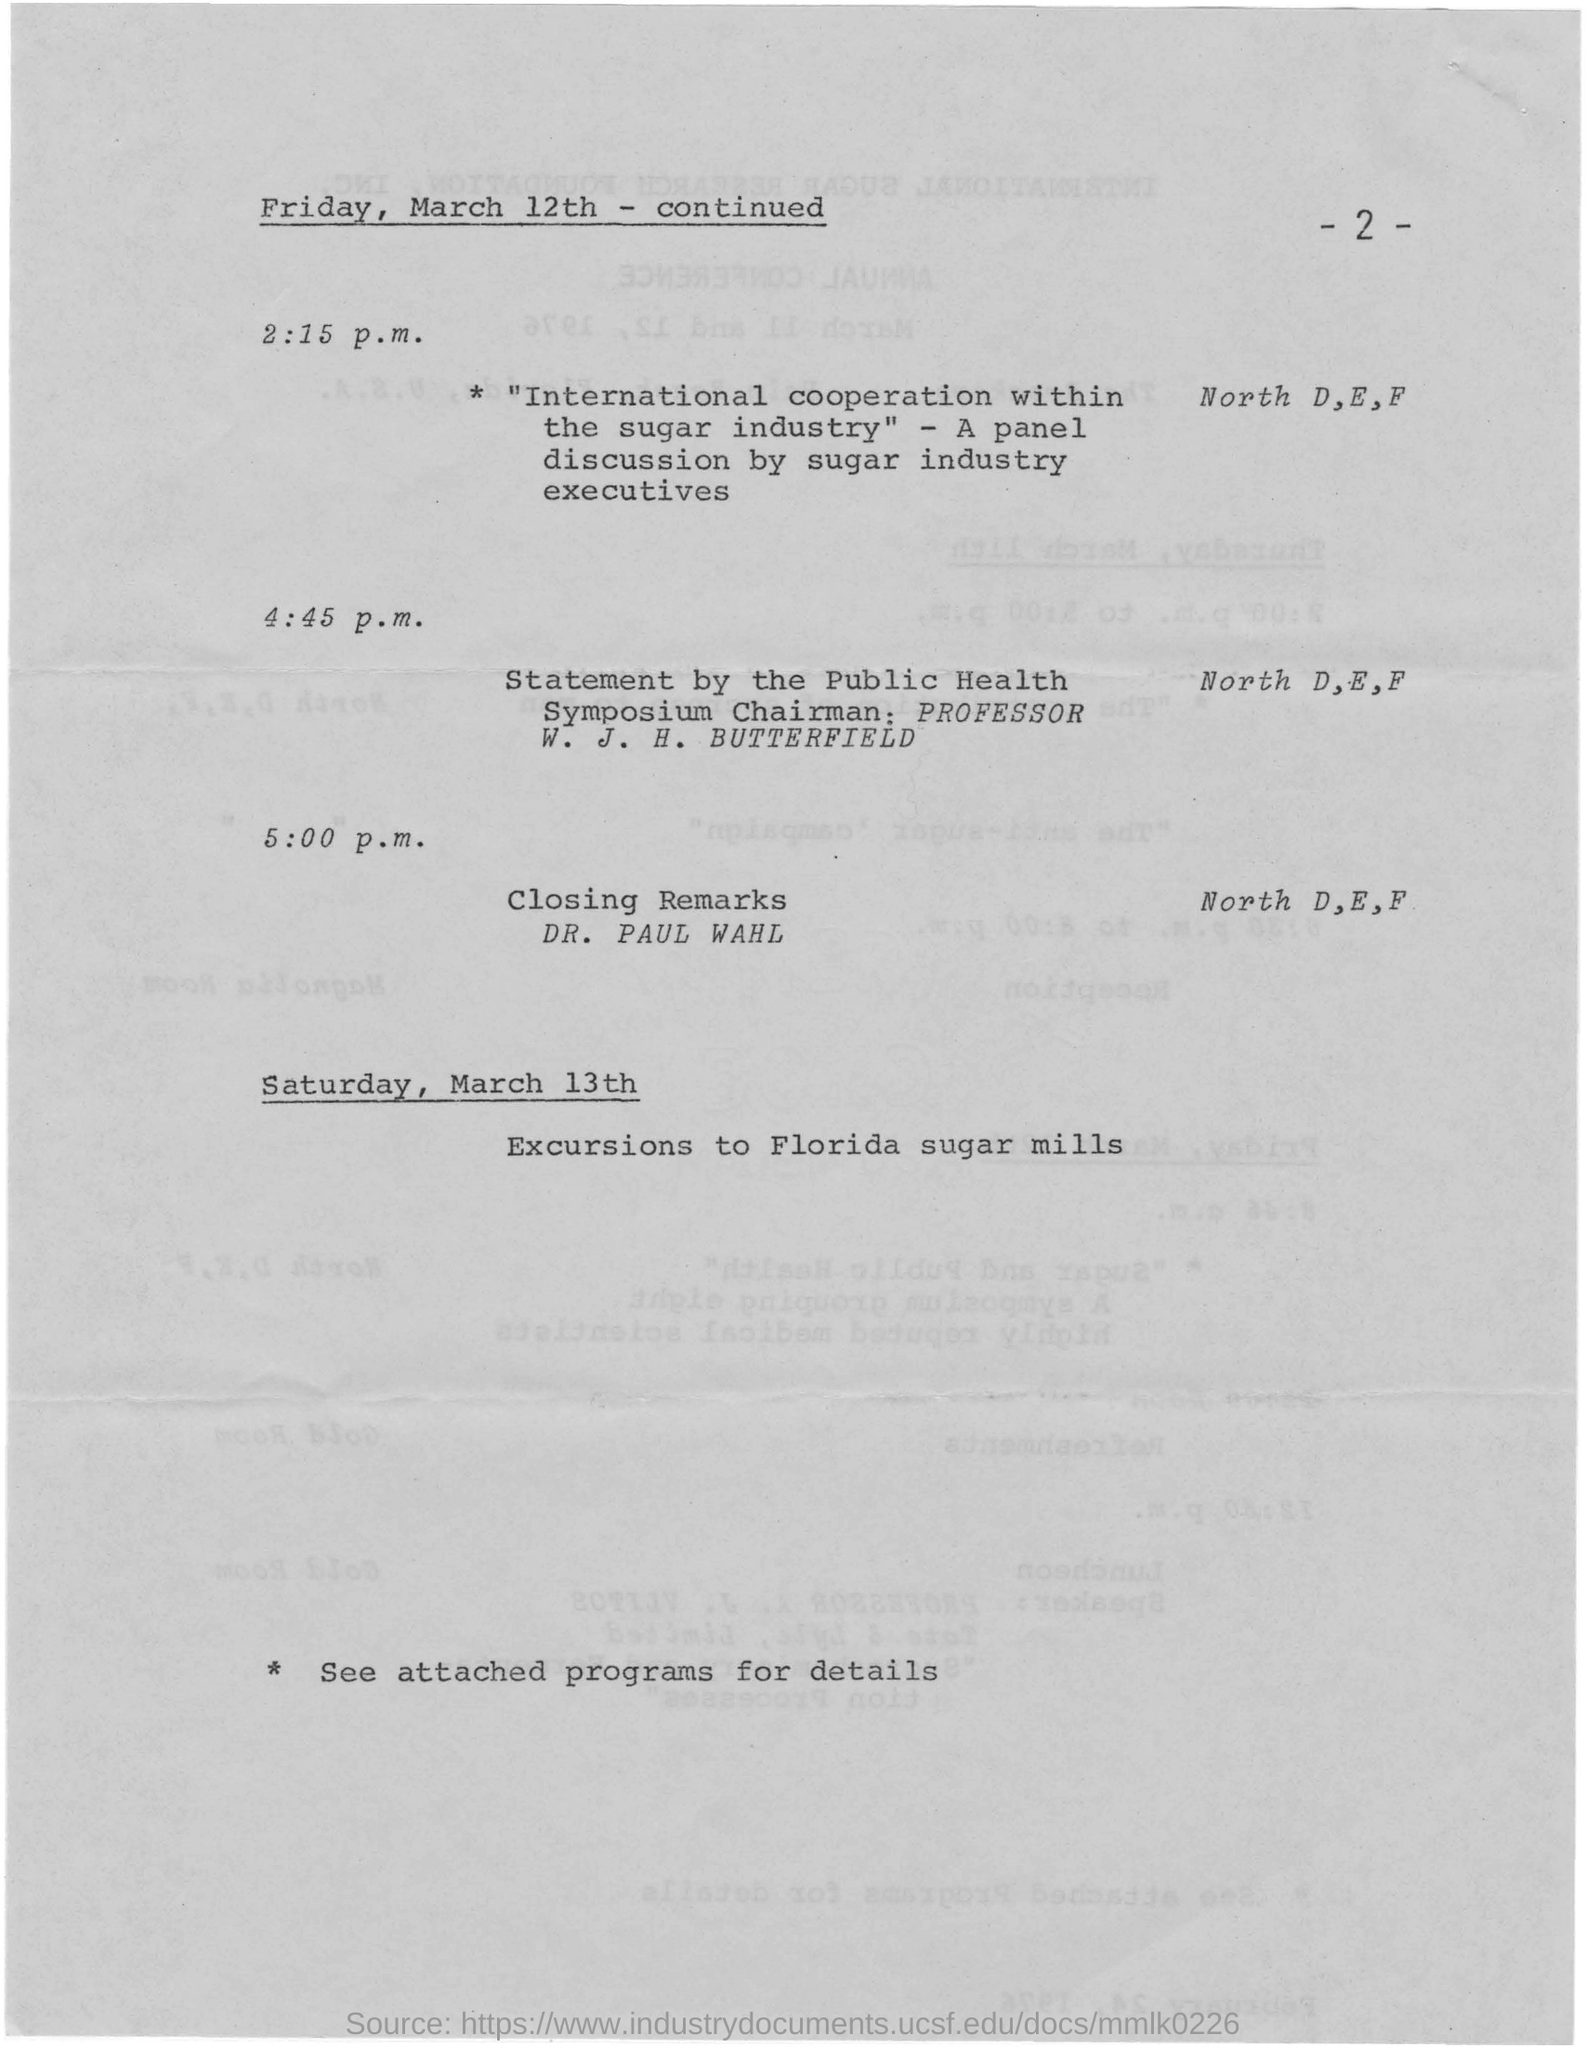Outline some significant characteristics in this image. The page number mentioned in this document is 2. The closing remarks will take place at 5:00 p.m. The excursions to the Florida sugar mills will take place on SATURDAY, MARCH 13TH. 